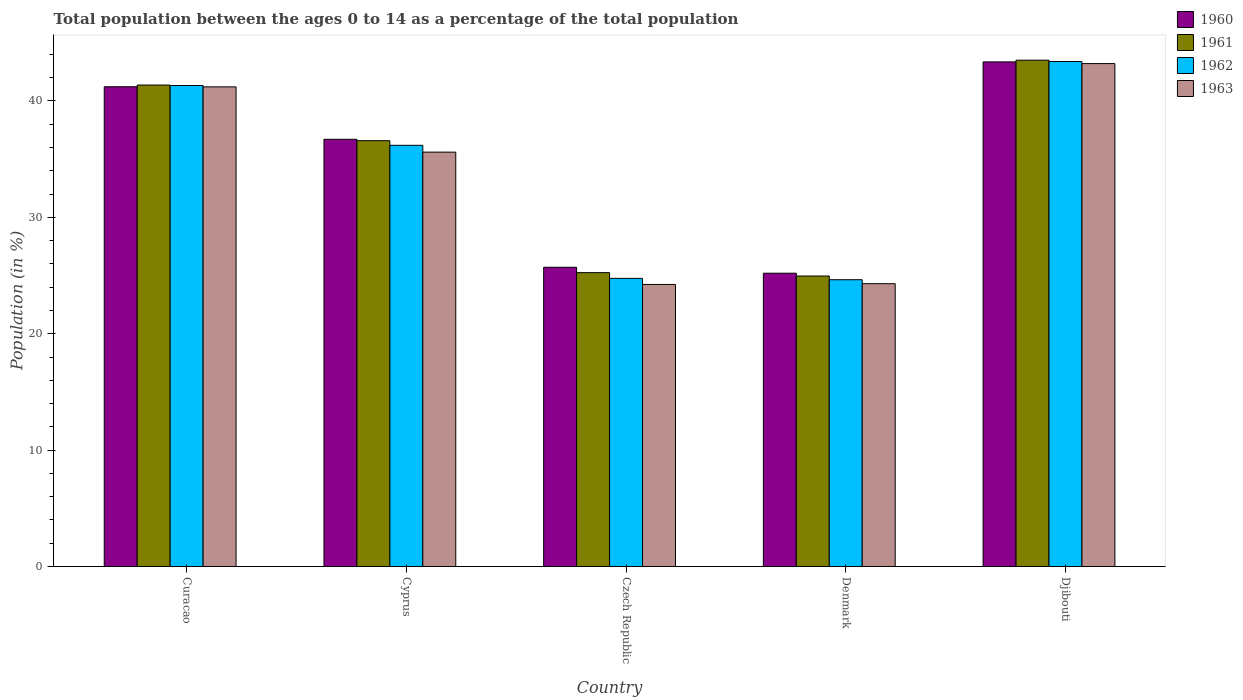How many different coloured bars are there?
Make the answer very short. 4. How many groups of bars are there?
Give a very brief answer. 5. How many bars are there on the 2nd tick from the right?
Provide a succinct answer. 4. What is the label of the 1st group of bars from the left?
Keep it short and to the point. Curacao. In how many cases, is the number of bars for a given country not equal to the number of legend labels?
Make the answer very short. 0. What is the percentage of the population ages 0 to 14 in 1962 in Cyprus?
Your answer should be very brief. 36.19. Across all countries, what is the maximum percentage of the population ages 0 to 14 in 1961?
Offer a very short reply. 43.5. Across all countries, what is the minimum percentage of the population ages 0 to 14 in 1960?
Offer a very short reply. 25.2. In which country was the percentage of the population ages 0 to 14 in 1962 maximum?
Give a very brief answer. Djibouti. In which country was the percentage of the population ages 0 to 14 in 1963 minimum?
Provide a succinct answer. Czech Republic. What is the total percentage of the population ages 0 to 14 in 1963 in the graph?
Provide a short and direct response. 168.57. What is the difference between the percentage of the population ages 0 to 14 in 1963 in Curacao and that in Djibouti?
Offer a terse response. -2. What is the difference between the percentage of the population ages 0 to 14 in 1960 in Czech Republic and the percentage of the population ages 0 to 14 in 1963 in Djibouti?
Give a very brief answer. -17.5. What is the average percentage of the population ages 0 to 14 in 1961 per country?
Your answer should be very brief. 34.33. What is the difference between the percentage of the population ages 0 to 14 of/in 1961 and percentage of the population ages 0 to 14 of/in 1960 in Djibouti?
Offer a very short reply. 0.15. In how many countries, is the percentage of the population ages 0 to 14 in 1962 greater than 24?
Your response must be concise. 5. What is the ratio of the percentage of the population ages 0 to 14 in 1960 in Curacao to that in Czech Republic?
Provide a succinct answer. 1.6. Is the percentage of the population ages 0 to 14 in 1963 in Denmark less than that in Djibouti?
Your answer should be very brief. Yes. What is the difference between the highest and the second highest percentage of the population ages 0 to 14 in 1962?
Provide a succinct answer. -2.06. What is the difference between the highest and the lowest percentage of the population ages 0 to 14 in 1963?
Offer a very short reply. 18.98. Is the sum of the percentage of the population ages 0 to 14 in 1963 in Curacao and Cyprus greater than the maximum percentage of the population ages 0 to 14 in 1962 across all countries?
Your answer should be very brief. Yes. What does the 2nd bar from the left in Cyprus represents?
Your response must be concise. 1961. What does the 4th bar from the right in Denmark represents?
Provide a succinct answer. 1960. Is it the case that in every country, the sum of the percentage of the population ages 0 to 14 in 1961 and percentage of the population ages 0 to 14 in 1960 is greater than the percentage of the population ages 0 to 14 in 1963?
Ensure brevity in your answer.  Yes. How many bars are there?
Your answer should be very brief. 20. What is the difference between two consecutive major ticks on the Y-axis?
Ensure brevity in your answer.  10. Are the values on the major ticks of Y-axis written in scientific E-notation?
Make the answer very short. No. Where does the legend appear in the graph?
Give a very brief answer. Top right. How are the legend labels stacked?
Keep it short and to the point. Vertical. What is the title of the graph?
Provide a succinct answer. Total population between the ages 0 to 14 as a percentage of the total population. What is the Population (in %) in 1960 in Curacao?
Keep it short and to the point. 41.22. What is the Population (in %) in 1961 in Curacao?
Offer a very short reply. 41.37. What is the Population (in %) in 1962 in Curacao?
Your response must be concise. 41.33. What is the Population (in %) of 1963 in Curacao?
Provide a short and direct response. 41.21. What is the Population (in %) in 1960 in Cyprus?
Provide a short and direct response. 36.71. What is the Population (in %) in 1961 in Cyprus?
Make the answer very short. 36.59. What is the Population (in %) of 1962 in Cyprus?
Offer a terse response. 36.19. What is the Population (in %) of 1963 in Cyprus?
Provide a short and direct response. 35.6. What is the Population (in %) of 1960 in Czech Republic?
Make the answer very short. 25.71. What is the Population (in %) in 1961 in Czech Republic?
Offer a terse response. 25.25. What is the Population (in %) of 1962 in Czech Republic?
Keep it short and to the point. 24.76. What is the Population (in %) of 1963 in Czech Republic?
Give a very brief answer. 24.23. What is the Population (in %) in 1960 in Denmark?
Offer a very short reply. 25.2. What is the Population (in %) of 1961 in Denmark?
Ensure brevity in your answer.  24.96. What is the Population (in %) in 1962 in Denmark?
Ensure brevity in your answer.  24.64. What is the Population (in %) in 1963 in Denmark?
Provide a short and direct response. 24.3. What is the Population (in %) in 1960 in Djibouti?
Keep it short and to the point. 43.36. What is the Population (in %) of 1961 in Djibouti?
Give a very brief answer. 43.5. What is the Population (in %) in 1962 in Djibouti?
Your answer should be very brief. 43.39. What is the Population (in %) of 1963 in Djibouti?
Provide a succinct answer. 43.21. Across all countries, what is the maximum Population (in %) of 1960?
Keep it short and to the point. 43.36. Across all countries, what is the maximum Population (in %) of 1961?
Your answer should be very brief. 43.5. Across all countries, what is the maximum Population (in %) in 1962?
Your answer should be compact. 43.39. Across all countries, what is the maximum Population (in %) in 1963?
Make the answer very short. 43.21. Across all countries, what is the minimum Population (in %) in 1960?
Your answer should be very brief. 25.2. Across all countries, what is the minimum Population (in %) in 1961?
Keep it short and to the point. 24.96. Across all countries, what is the minimum Population (in %) in 1962?
Provide a short and direct response. 24.64. Across all countries, what is the minimum Population (in %) of 1963?
Your response must be concise. 24.23. What is the total Population (in %) of 1960 in the graph?
Provide a short and direct response. 172.2. What is the total Population (in %) in 1961 in the graph?
Your answer should be compact. 171.67. What is the total Population (in %) in 1962 in the graph?
Your answer should be compact. 170.31. What is the total Population (in %) of 1963 in the graph?
Make the answer very short. 168.57. What is the difference between the Population (in %) of 1960 in Curacao and that in Cyprus?
Ensure brevity in your answer.  4.52. What is the difference between the Population (in %) of 1961 in Curacao and that in Cyprus?
Provide a succinct answer. 4.78. What is the difference between the Population (in %) in 1962 in Curacao and that in Cyprus?
Ensure brevity in your answer.  5.14. What is the difference between the Population (in %) of 1963 in Curacao and that in Cyprus?
Provide a succinct answer. 5.61. What is the difference between the Population (in %) of 1960 in Curacao and that in Czech Republic?
Give a very brief answer. 15.51. What is the difference between the Population (in %) in 1961 in Curacao and that in Czech Republic?
Offer a very short reply. 16.12. What is the difference between the Population (in %) of 1962 in Curacao and that in Czech Republic?
Your response must be concise. 16.57. What is the difference between the Population (in %) in 1963 in Curacao and that in Czech Republic?
Make the answer very short. 16.98. What is the difference between the Population (in %) of 1960 in Curacao and that in Denmark?
Make the answer very short. 16.02. What is the difference between the Population (in %) in 1961 in Curacao and that in Denmark?
Your answer should be compact. 16.41. What is the difference between the Population (in %) of 1962 in Curacao and that in Denmark?
Make the answer very short. 16.69. What is the difference between the Population (in %) of 1963 in Curacao and that in Denmark?
Your answer should be compact. 16.91. What is the difference between the Population (in %) of 1960 in Curacao and that in Djibouti?
Offer a terse response. -2.14. What is the difference between the Population (in %) in 1961 in Curacao and that in Djibouti?
Offer a terse response. -2.13. What is the difference between the Population (in %) in 1962 in Curacao and that in Djibouti?
Your response must be concise. -2.06. What is the difference between the Population (in %) of 1963 in Curacao and that in Djibouti?
Give a very brief answer. -2. What is the difference between the Population (in %) in 1960 in Cyprus and that in Czech Republic?
Give a very brief answer. 11. What is the difference between the Population (in %) in 1961 in Cyprus and that in Czech Republic?
Your answer should be very brief. 11.34. What is the difference between the Population (in %) of 1962 in Cyprus and that in Czech Republic?
Ensure brevity in your answer.  11.43. What is the difference between the Population (in %) in 1963 in Cyprus and that in Czech Republic?
Offer a terse response. 11.37. What is the difference between the Population (in %) in 1960 in Cyprus and that in Denmark?
Your answer should be very brief. 11.51. What is the difference between the Population (in %) in 1961 in Cyprus and that in Denmark?
Ensure brevity in your answer.  11.63. What is the difference between the Population (in %) of 1962 in Cyprus and that in Denmark?
Your response must be concise. 11.55. What is the difference between the Population (in %) in 1963 in Cyprus and that in Denmark?
Offer a very short reply. 11.3. What is the difference between the Population (in %) in 1960 in Cyprus and that in Djibouti?
Make the answer very short. -6.65. What is the difference between the Population (in %) of 1961 in Cyprus and that in Djibouti?
Your answer should be very brief. -6.92. What is the difference between the Population (in %) in 1962 in Cyprus and that in Djibouti?
Provide a short and direct response. -7.2. What is the difference between the Population (in %) of 1963 in Cyprus and that in Djibouti?
Make the answer very short. -7.61. What is the difference between the Population (in %) of 1960 in Czech Republic and that in Denmark?
Make the answer very short. 0.51. What is the difference between the Population (in %) of 1961 in Czech Republic and that in Denmark?
Your answer should be compact. 0.29. What is the difference between the Population (in %) of 1962 in Czech Republic and that in Denmark?
Your response must be concise. 0.12. What is the difference between the Population (in %) of 1963 in Czech Republic and that in Denmark?
Offer a very short reply. -0.07. What is the difference between the Population (in %) in 1960 in Czech Republic and that in Djibouti?
Offer a terse response. -17.65. What is the difference between the Population (in %) of 1961 in Czech Republic and that in Djibouti?
Your answer should be very brief. -18.26. What is the difference between the Population (in %) in 1962 in Czech Republic and that in Djibouti?
Make the answer very short. -18.64. What is the difference between the Population (in %) of 1963 in Czech Republic and that in Djibouti?
Provide a short and direct response. -18.98. What is the difference between the Population (in %) in 1960 in Denmark and that in Djibouti?
Ensure brevity in your answer.  -18.16. What is the difference between the Population (in %) of 1961 in Denmark and that in Djibouti?
Offer a very short reply. -18.55. What is the difference between the Population (in %) of 1962 in Denmark and that in Djibouti?
Give a very brief answer. -18.75. What is the difference between the Population (in %) in 1963 in Denmark and that in Djibouti?
Offer a terse response. -18.91. What is the difference between the Population (in %) in 1960 in Curacao and the Population (in %) in 1961 in Cyprus?
Keep it short and to the point. 4.64. What is the difference between the Population (in %) in 1960 in Curacao and the Population (in %) in 1962 in Cyprus?
Provide a succinct answer. 5.03. What is the difference between the Population (in %) of 1960 in Curacao and the Population (in %) of 1963 in Cyprus?
Give a very brief answer. 5.62. What is the difference between the Population (in %) in 1961 in Curacao and the Population (in %) in 1962 in Cyprus?
Provide a succinct answer. 5.18. What is the difference between the Population (in %) in 1961 in Curacao and the Population (in %) in 1963 in Cyprus?
Offer a very short reply. 5.77. What is the difference between the Population (in %) of 1962 in Curacao and the Population (in %) of 1963 in Cyprus?
Offer a terse response. 5.72. What is the difference between the Population (in %) of 1960 in Curacao and the Population (in %) of 1961 in Czech Republic?
Give a very brief answer. 15.97. What is the difference between the Population (in %) of 1960 in Curacao and the Population (in %) of 1962 in Czech Republic?
Give a very brief answer. 16.47. What is the difference between the Population (in %) of 1960 in Curacao and the Population (in %) of 1963 in Czech Republic?
Make the answer very short. 16.99. What is the difference between the Population (in %) in 1961 in Curacao and the Population (in %) in 1962 in Czech Republic?
Keep it short and to the point. 16.61. What is the difference between the Population (in %) of 1961 in Curacao and the Population (in %) of 1963 in Czech Republic?
Your response must be concise. 17.14. What is the difference between the Population (in %) in 1962 in Curacao and the Population (in %) in 1963 in Czech Republic?
Your answer should be compact. 17.09. What is the difference between the Population (in %) in 1960 in Curacao and the Population (in %) in 1961 in Denmark?
Provide a short and direct response. 16.26. What is the difference between the Population (in %) in 1960 in Curacao and the Population (in %) in 1962 in Denmark?
Ensure brevity in your answer.  16.58. What is the difference between the Population (in %) in 1960 in Curacao and the Population (in %) in 1963 in Denmark?
Provide a succinct answer. 16.92. What is the difference between the Population (in %) in 1961 in Curacao and the Population (in %) in 1962 in Denmark?
Offer a terse response. 16.73. What is the difference between the Population (in %) in 1961 in Curacao and the Population (in %) in 1963 in Denmark?
Provide a succinct answer. 17.07. What is the difference between the Population (in %) of 1962 in Curacao and the Population (in %) of 1963 in Denmark?
Offer a very short reply. 17.03. What is the difference between the Population (in %) in 1960 in Curacao and the Population (in %) in 1961 in Djibouti?
Give a very brief answer. -2.28. What is the difference between the Population (in %) of 1960 in Curacao and the Population (in %) of 1962 in Djibouti?
Provide a succinct answer. -2.17. What is the difference between the Population (in %) of 1960 in Curacao and the Population (in %) of 1963 in Djibouti?
Give a very brief answer. -1.99. What is the difference between the Population (in %) of 1961 in Curacao and the Population (in %) of 1962 in Djibouti?
Your answer should be very brief. -2.02. What is the difference between the Population (in %) in 1961 in Curacao and the Population (in %) in 1963 in Djibouti?
Your response must be concise. -1.84. What is the difference between the Population (in %) in 1962 in Curacao and the Population (in %) in 1963 in Djibouti?
Your response must be concise. -1.88. What is the difference between the Population (in %) of 1960 in Cyprus and the Population (in %) of 1961 in Czech Republic?
Give a very brief answer. 11.46. What is the difference between the Population (in %) of 1960 in Cyprus and the Population (in %) of 1962 in Czech Republic?
Provide a short and direct response. 11.95. What is the difference between the Population (in %) of 1960 in Cyprus and the Population (in %) of 1963 in Czech Republic?
Your response must be concise. 12.47. What is the difference between the Population (in %) in 1961 in Cyprus and the Population (in %) in 1962 in Czech Republic?
Provide a succinct answer. 11.83. What is the difference between the Population (in %) in 1961 in Cyprus and the Population (in %) in 1963 in Czech Republic?
Offer a very short reply. 12.35. What is the difference between the Population (in %) in 1962 in Cyprus and the Population (in %) in 1963 in Czech Republic?
Provide a succinct answer. 11.96. What is the difference between the Population (in %) in 1960 in Cyprus and the Population (in %) in 1961 in Denmark?
Provide a short and direct response. 11.75. What is the difference between the Population (in %) of 1960 in Cyprus and the Population (in %) of 1962 in Denmark?
Give a very brief answer. 12.07. What is the difference between the Population (in %) of 1960 in Cyprus and the Population (in %) of 1963 in Denmark?
Make the answer very short. 12.41. What is the difference between the Population (in %) in 1961 in Cyprus and the Population (in %) in 1962 in Denmark?
Your answer should be compact. 11.95. What is the difference between the Population (in %) of 1961 in Cyprus and the Population (in %) of 1963 in Denmark?
Provide a succinct answer. 12.29. What is the difference between the Population (in %) in 1962 in Cyprus and the Population (in %) in 1963 in Denmark?
Provide a short and direct response. 11.89. What is the difference between the Population (in %) in 1960 in Cyprus and the Population (in %) in 1961 in Djibouti?
Make the answer very short. -6.8. What is the difference between the Population (in %) in 1960 in Cyprus and the Population (in %) in 1962 in Djibouti?
Provide a short and direct response. -6.69. What is the difference between the Population (in %) in 1960 in Cyprus and the Population (in %) in 1963 in Djibouti?
Provide a short and direct response. -6.51. What is the difference between the Population (in %) in 1961 in Cyprus and the Population (in %) in 1962 in Djibouti?
Give a very brief answer. -6.81. What is the difference between the Population (in %) of 1961 in Cyprus and the Population (in %) of 1963 in Djibouti?
Your answer should be very brief. -6.63. What is the difference between the Population (in %) of 1962 in Cyprus and the Population (in %) of 1963 in Djibouti?
Your answer should be compact. -7.02. What is the difference between the Population (in %) of 1960 in Czech Republic and the Population (in %) of 1961 in Denmark?
Offer a very short reply. 0.75. What is the difference between the Population (in %) in 1960 in Czech Republic and the Population (in %) in 1962 in Denmark?
Keep it short and to the point. 1.07. What is the difference between the Population (in %) of 1960 in Czech Republic and the Population (in %) of 1963 in Denmark?
Offer a very short reply. 1.41. What is the difference between the Population (in %) in 1961 in Czech Republic and the Population (in %) in 1962 in Denmark?
Keep it short and to the point. 0.61. What is the difference between the Population (in %) in 1961 in Czech Republic and the Population (in %) in 1963 in Denmark?
Offer a terse response. 0.95. What is the difference between the Population (in %) of 1962 in Czech Republic and the Population (in %) of 1963 in Denmark?
Your answer should be very brief. 0.46. What is the difference between the Population (in %) of 1960 in Czech Republic and the Population (in %) of 1961 in Djibouti?
Your response must be concise. -17.79. What is the difference between the Population (in %) in 1960 in Czech Republic and the Population (in %) in 1962 in Djibouti?
Give a very brief answer. -17.68. What is the difference between the Population (in %) in 1960 in Czech Republic and the Population (in %) in 1963 in Djibouti?
Your response must be concise. -17.5. What is the difference between the Population (in %) of 1961 in Czech Republic and the Population (in %) of 1962 in Djibouti?
Your answer should be compact. -18.14. What is the difference between the Population (in %) in 1961 in Czech Republic and the Population (in %) in 1963 in Djibouti?
Your response must be concise. -17.96. What is the difference between the Population (in %) of 1962 in Czech Republic and the Population (in %) of 1963 in Djibouti?
Offer a terse response. -18.46. What is the difference between the Population (in %) in 1960 in Denmark and the Population (in %) in 1961 in Djibouti?
Make the answer very short. -18.3. What is the difference between the Population (in %) of 1960 in Denmark and the Population (in %) of 1962 in Djibouti?
Offer a very short reply. -18.19. What is the difference between the Population (in %) of 1960 in Denmark and the Population (in %) of 1963 in Djibouti?
Give a very brief answer. -18.01. What is the difference between the Population (in %) of 1961 in Denmark and the Population (in %) of 1962 in Djibouti?
Provide a short and direct response. -18.43. What is the difference between the Population (in %) in 1961 in Denmark and the Population (in %) in 1963 in Djibouti?
Offer a terse response. -18.25. What is the difference between the Population (in %) in 1962 in Denmark and the Population (in %) in 1963 in Djibouti?
Provide a succinct answer. -18.57. What is the average Population (in %) in 1960 per country?
Keep it short and to the point. 34.44. What is the average Population (in %) of 1961 per country?
Your answer should be very brief. 34.33. What is the average Population (in %) of 1962 per country?
Keep it short and to the point. 34.06. What is the average Population (in %) of 1963 per country?
Provide a short and direct response. 33.71. What is the difference between the Population (in %) in 1960 and Population (in %) in 1961 in Curacao?
Give a very brief answer. -0.15. What is the difference between the Population (in %) in 1960 and Population (in %) in 1962 in Curacao?
Your response must be concise. -0.11. What is the difference between the Population (in %) of 1960 and Population (in %) of 1963 in Curacao?
Your answer should be very brief. 0.01. What is the difference between the Population (in %) of 1961 and Population (in %) of 1962 in Curacao?
Your response must be concise. 0.04. What is the difference between the Population (in %) of 1961 and Population (in %) of 1963 in Curacao?
Give a very brief answer. 0.16. What is the difference between the Population (in %) in 1962 and Population (in %) in 1963 in Curacao?
Your answer should be compact. 0.12. What is the difference between the Population (in %) of 1960 and Population (in %) of 1961 in Cyprus?
Keep it short and to the point. 0.12. What is the difference between the Population (in %) in 1960 and Population (in %) in 1962 in Cyprus?
Give a very brief answer. 0.52. What is the difference between the Population (in %) of 1960 and Population (in %) of 1963 in Cyprus?
Give a very brief answer. 1.1. What is the difference between the Population (in %) in 1961 and Population (in %) in 1962 in Cyprus?
Provide a succinct answer. 0.4. What is the difference between the Population (in %) of 1961 and Population (in %) of 1963 in Cyprus?
Provide a succinct answer. 0.98. What is the difference between the Population (in %) of 1962 and Population (in %) of 1963 in Cyprus?
Provide a succinct answer. 0.59. What is the difference between the Population (in %) of 1960 and Population (in %) of 1961 in Czech Republic?
Make the answer very short. 0.46. What is the difference between the Population (in %) of 1960 and Population (in %) of 1962 in Czech Republic?
Your response must be concise. 0.95. What is the difference between the Population (in %) of 1960 and Population (in %) of 1963 in Czech Republic?
Provide a succinct answer. 1.48. What is the difference between the Population (in %) of 1961 and Population (in %) of 1962 in Czech Republic?
Provide a short and direct response. 0.49. What is the difference between the Population (in %) in 1961 and Population (in %) in 1963 in Czech Republic?
Offer a terse response. 1.01. What is the difference between the Population (in %) in 1962 and Population (in %) in 1963 in Czech Republic?
Ensure brevity in your answer.  0.52. What is the difference between the Population (in %) in 1960 and Population (in %) in 1961 in Denmark?
Provide a short and direct response. 0.24. What is the difference between the Population (in %) of 1960 and Population (in %) of 1962 in Denmark?
Ensure brevity in your answer.  0.56. What is the difference between the Population (in %) of 1960 and Population (in %) of 1963 in Denmark?
Provide a short and direct response. 0.9. What is the difference between the Population (in %) in 1961 and Population (in %) in 1962 in Denmark?
Offer a terse response. 0.32. What is the difference between the Population (in %) of 1961 and Population (in %) of 1963 in Denmark?
Offer a very short reply. 0.66. What is the difference between the Population (in %) in 1962 and Population (in %) in 1963 in Denmark?
Provide a short and direct response. 0.34. What is the difference between the Population (in %) in 1960 and Population (in %) in 1961 in Djibouti?
Offer a terse response. -0.15. What is the difference between the Population (in %) of 1960 and Population (in %) of 1962 in Djibouti?
Provide a short and direct response. -0.03. What is the difference between the Population (in %) of 1960 and Population (in %) of 1963 in Djibouti?
Your response must be concise. 0.14. What is the difference between the Population (in %) in 1961 and Population (in %) in 1962 in Djibouti?
Ensure brevity in your answer.  0.11. What is the difference between the Population (in %) in 1961 and Population (in %) in 1963 in Djibouti?
Ensure brevity in your answer.  0.29. What is the difference between the Population (in %) of 1962 and Population (in %) of 1963 in Djibouti?
Your answer should be very brief. 0.18. What is the ratio of the Population (in %) of 1960 in Curacao to that in Cyprus?
Provide a succinct answer. 1.12. What is the ratio of the Population (in %) in 1961 in Curacao to that in Cyprus?
Offer a terse response. 1.13. What is the ratio of the Population (in %) in 1962 in Curacao to that in Cyprus?
Your answer should be compact. 1.14. What is the ratio of the Population (in %) in 1963 in Curacao to that in Cyprus?
Offer a terse response. 1.16. What is the ratio of the Population (in %) in 1960 in Curacao to that in Czech Republic?
Your answer should be compact. 1.6. What is the ratio of the Population (in %) in 1961 in Curacao to that in Czech Republic?
Offer a terse response. 1.64. What is the ratio of the Population (in %) of 1962 in Curacao to that in Czech Republic?
Give a very brief answer. 1.67. What is the ratio of the Population (in %) of 1963 in Curacao to that in Czech Republic?
Your response must be concise. 1.7. What is the ratio of the Population (in %) in 1960 in Curacao to that in Denmark?
Make the answer very short. 1.64. What is the ratio of the Population (in %) in 1961 in Curacao to that in Denmark?
Keep it short and to the point. 1.66. What is the ratio of the Population (in %) of 1962 in Curacao to that in Denmark?
Provide a succinct answer. 1.68. What is the ratio of the Population (in %) of 1963 in Curacao to that in Denmark?
Give a very brief answer. 1.7. What is the ratio of the Population (in %) of 1960 in Curacao to that in Djibouti?
Your answer should be compact. 0.95. What is the ratio of the Population (in %) in 1961 in Curacao to that in Djibouti?
Ensure brevity in your answer.  0.95. What is the ratio of the Population (in %) in 1963 in Curacao to that in Djibouti?
Provide a short and direct response. 0.95. What is the ratio of the Population (in %) in 1960 in Cyprus to that in Czech Republic?
Your answer should be very brief. 1.43. What is the ratio of the Population (in %) in 1961 in Cyprus to that in Czech Republic?
Ensure brevity in your answer.  1.45. What is the ratio of the Population (in %) in 1962 in Cyprus to that in Czech Republic?
Provide a short and direct response. 1.46. What is the ratio of the Population (in %) in 1963 in Cyprus to that in Czech Republic?
Your answer should be very brief. 1.47. What is the ratio of the Population (in %) of 1960 in Cyprus to that in Denmark?
Provide a short and direct response. 1.46. What is the ratio of the Population (in %) of 1961 in Cyprus to that in Denmark?
Give a very brief answer. 1.47. What is the ratio of the Population (in %) in 1962 in Cyprus to that in Denmark?
Provide a succinct answer. 1.47. What is the ratio of the Population (in %) of 1963 in Cyprus to that in Denmark?
Give a very brief answer. 1.47. What is the ratio of the Population (in %) of 1960 in Cyprus to that in Djibouti?
Offer a very short reply. 0.85. What is the ratio of the Population (in %) in 1961 in Cyprus to that in Djibouti?
Give a very brief answer. 0.84. What is the ratio of the Population (in %) of 1962 in Cyprus to that in Djibouti?
Provide a short and direct response. 0.83. What is the ratio of the Population (in %) in 1963 in Cyprus to that in Djibouti?
Offer a very short reply. 0.82. What is the ratio of the Population (in %) of 1960 in Czech Republic to that in Denmark?
Give a very brief answer. 1.02. What is the ratio of the Population (in %) in 1961 in Czech Republic to that in Denmark?
Provide a succinct answer. 1.01. What is the ratio of the Population (in %) of 1963 in Czech Republic to that in Denmark?
Offer a very short reply. 1. What is the ratio of the Population (in %) of 1960 in Czech Republic to that in Djibouti?
Offer a terse response. 0.59. What is the ratio of the Population (in %) of 1961 in Czech Republic to that in Djibouti?
Ensure brevity in your answer.  0.58. What is the ratio of the Population (in %) in 1962 in Czech Republic to that in Djibouti?
Make the answer very short. 0.57. What is the ratio of the Population (in %) of 1963 in Czech Republic to that in Djibouti?
Ensure brevity in your answer.  0.56. What is the ratio of the Population (in %) in 1960 in Denmark to that in Djibouti?
Offer a very short reply. 0.58. What is the ratio of the Population (in %) in 1961 in Denmark to that in Djibouti?
Your answer should be very brief. 0.57. What is the ratio of the Population (in %) of 1962 in Denmark to that in Djibouti?
Ensure brevity in your answer.  0.57. What is the ratio of the Population (in %) of 1963 in Denmark to that in Djibouti?
Your response must be concise. 0.56. What is the difference between the highest and the second highest Population (in %) of 1960?
Provide a short and direct response. 2.14. What is the difference between the highest and the second highest Population (in %) of 1961?
Your answer should be compact. 2.13. What is the difference between the highest and the second highest Population (in %) of 1962?
Keep it short and to the point. 2.06. What is the difference between the highest and the second highest Population (in %) in 1963?
Keep it short and to the point. 2. What is the difference between the highest and the lowest Population (in %) of 1960?
Provide a succinct answer. 18.16. What is the difference between the highest and the lowest Population (in %) in 1961?
Give a very brief answer. 18.55. What is the difference between the highest and the lowest Population (in %) in 1962?
Keep it short and to the point. 18.75. What is the difference between the highest and the lowest Population (in %) in 1963?
Give a very brief answer. 18.98. 